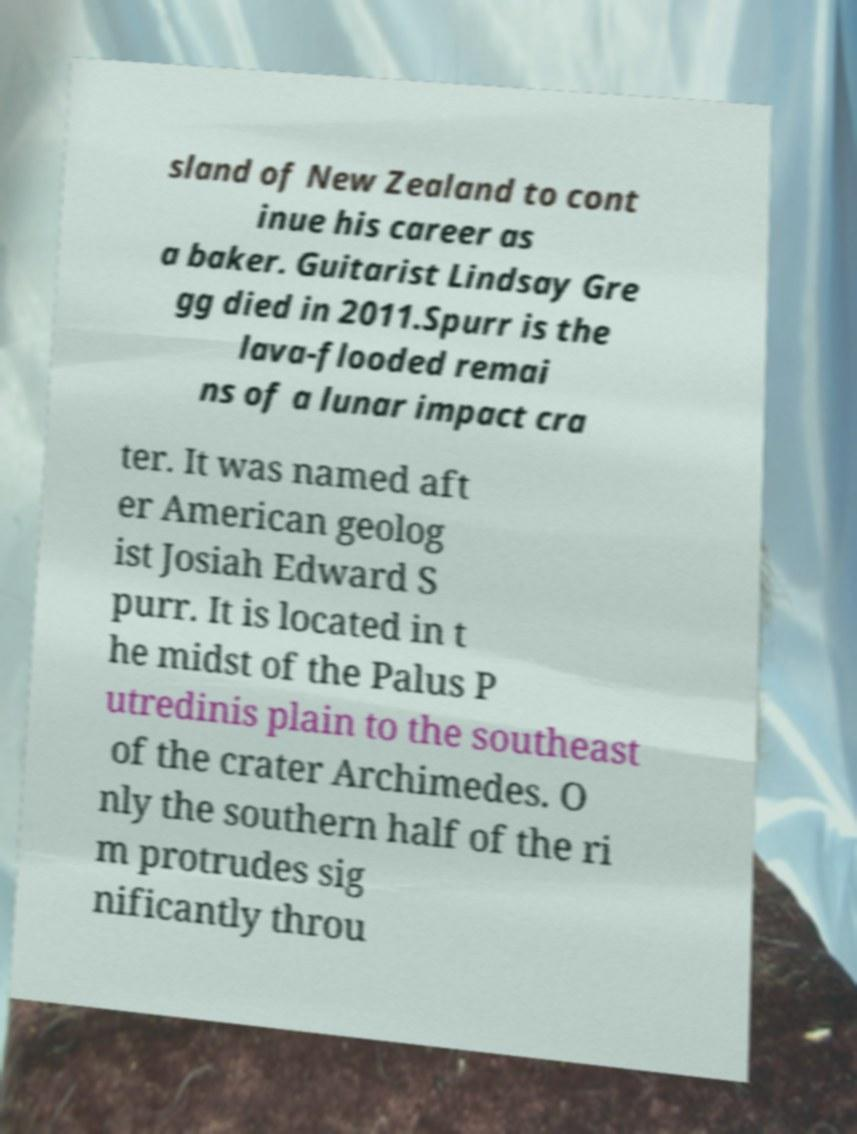Could you assist in decoding the text presented in this image and type it out clearly? sland of New Zealand to cont inue his career as a baker. Guitarist Lindsay Gre gg died in 2011.Spurr is the lava-flooded remai ns of a lunar impact cra ter. It was named aft er American geolog ist Josiah Edward S purr. It is located in t he midst of the Palus P utredinis plain to the southeast of the crater Archimedes. O nly the southern half of the ri m protrudes sig nificantly throu 